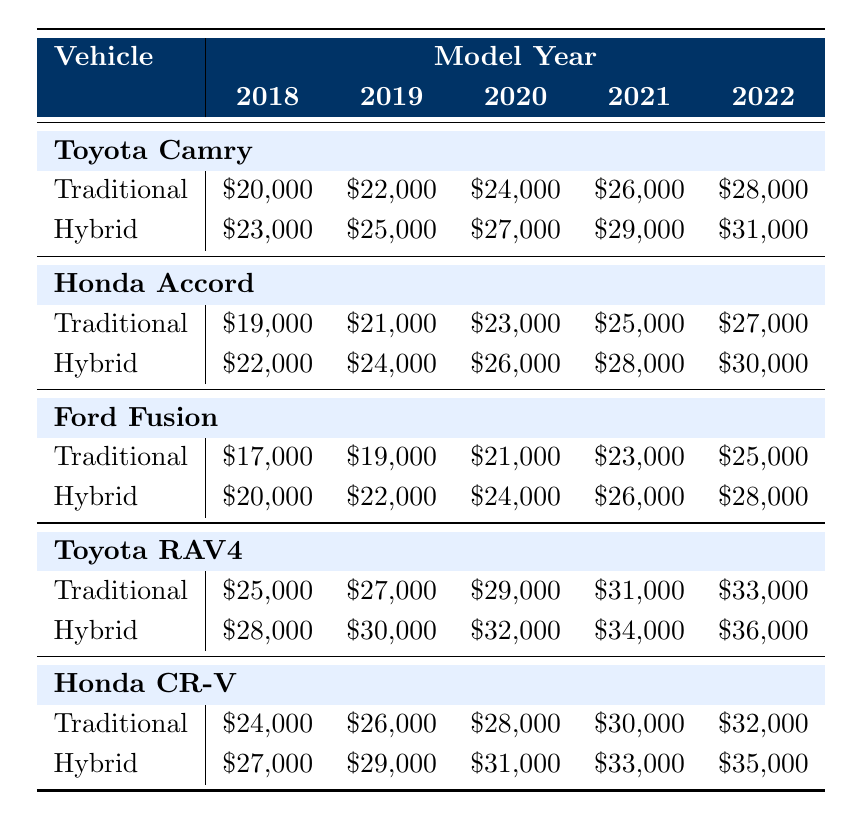What is the trade-in value of a 2020 Toyota Camry Hybrid? The table shows the trade-in value for a 2020 Toyota Camry Hybrid, which is listed under the Hybrid category and corresponds to the 2020 model year. The specified value is \$27,000.
Answer: $27,000 Which vehicle model has the highest trade-in value in 2021? To find the highest trade-in value in 2021, we compare the values of each vehicle model for that year. The values are: Toyota Camry \$26,000, Honda Accord \$25,000, Ford Fusion \$23,000, Toyota RAV4 \$31,000, and Honda CR-V \$30,000. The highest value is \$31,000 for the Toyota RAV4.
Answer: $31,000 Is the hybrid version of the Ford Fusion worth more than the traditional version in every model year listed? We compare the trade-in values of the Ford Fusion across all model years. Traditional values are \$17,000, \$19,000, \$21,000, \$23,000, \$25,000 for 2018 to 2022, respectively, and Hybrid values are \$20,000, \$22,000, \$24,000, \$26,000, \$28,000. In every year, Hybrid values exceed Traditional values, confirming that this statement is true.
Answer: Yes What is the average trade-in value of the Traditional vehicles for the year 2022? The trade-in values for Traditional vehicles in 2022 are as follows: Toyota Camry \$28,000, Honda Accord \$27,000, Ford Fusion \$25,000, Toyota RAV4 \$33,000, and Honda CR-V \$32,000. To calculate the average, we sum these values: \$28,000 + \$27,000 + \$25,000 + \$33,000 + \$32,000 = \$145,000. Then divide by the number of vehicles (5) giving an average of \$29,000.
Answer: $29,000 For which model year does the Toyota RAV4 Hybrid have the lowest trade-in value? We examine the values of the Toyota RAV4 Hybrid across the years: for 2018 \$28,000, 2019 \$30,000, 2020 \$32,000, 2021 \$34,000, and 2022 \$36,000. The lowest value is in 2018 at \$28,000.
Answer: 2018 